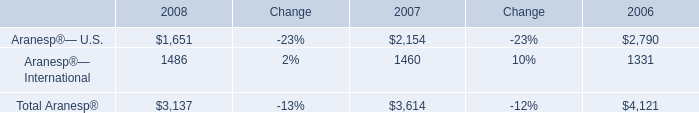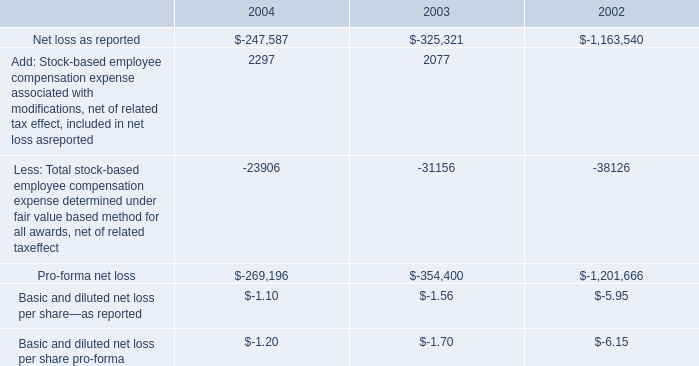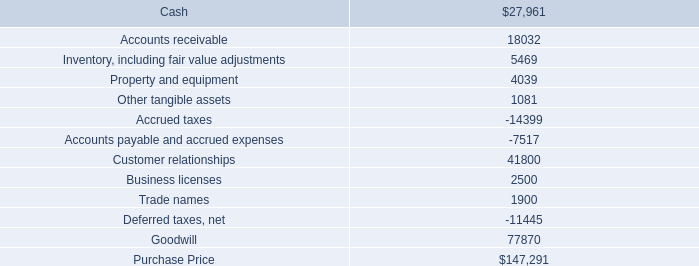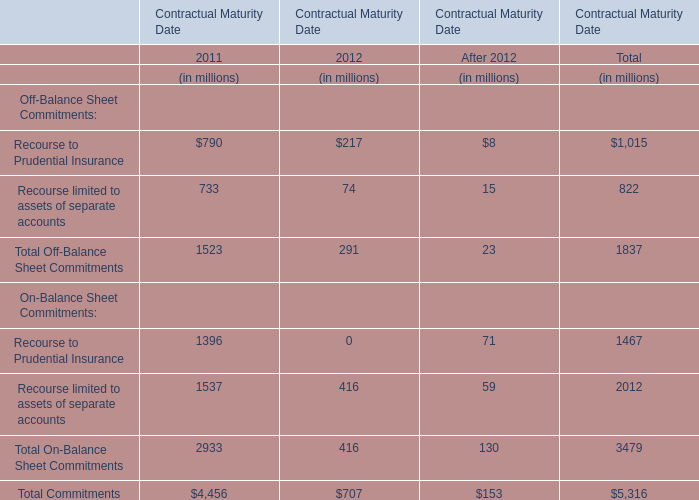Between 2011 and 2012,for Contractual Maturity Date what year is Total Off-Balance Sheet Commitments lower? 
Answer: 2012. 